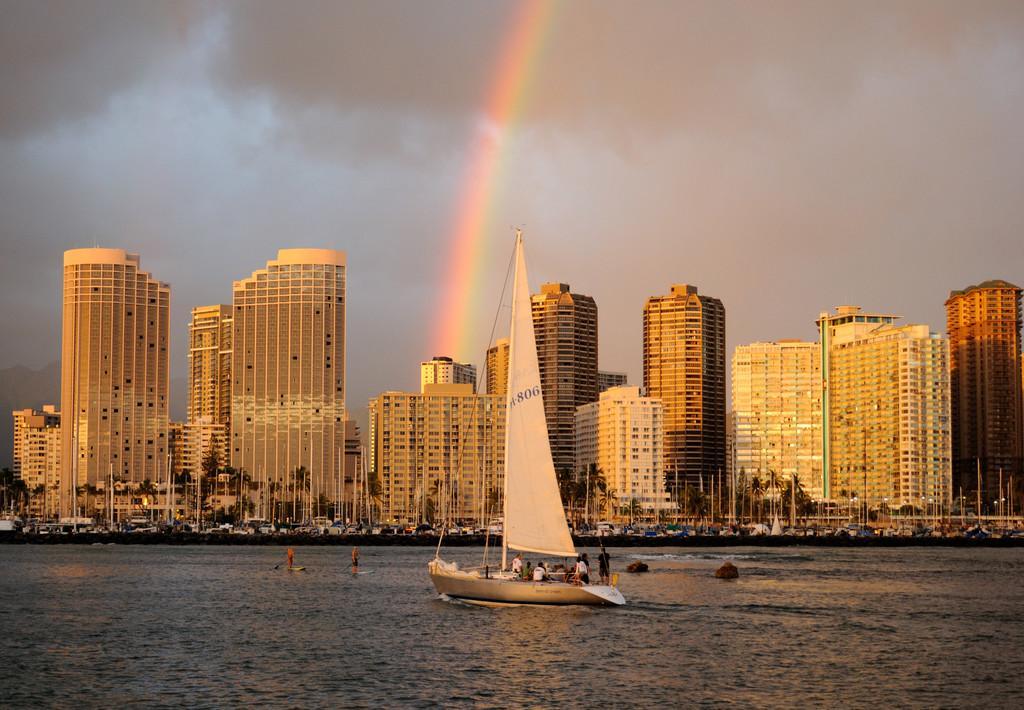Could you give a brief overview of what you see in this image? In the image there is a water surface and a ship is sailing on the water surface, behind that there are many tall buildings, trees, poles and some other things in the background. 